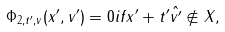<formula> <loc_0><loc_0><loc_500><loc_500>\Phi _ { 2 , t ^ { \prime } , v } ( x ^ { \prime } , v ^ { \prime } ) = 0 i f x ^ { \prime } + t ^ { \prime } \hat { v ^ { \prime } } \not \in X ,</formula> 